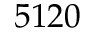Convert formula to latex. <formula><loc_0><loc_0><loc_500><loc_500>5 1 2 0</formula> 